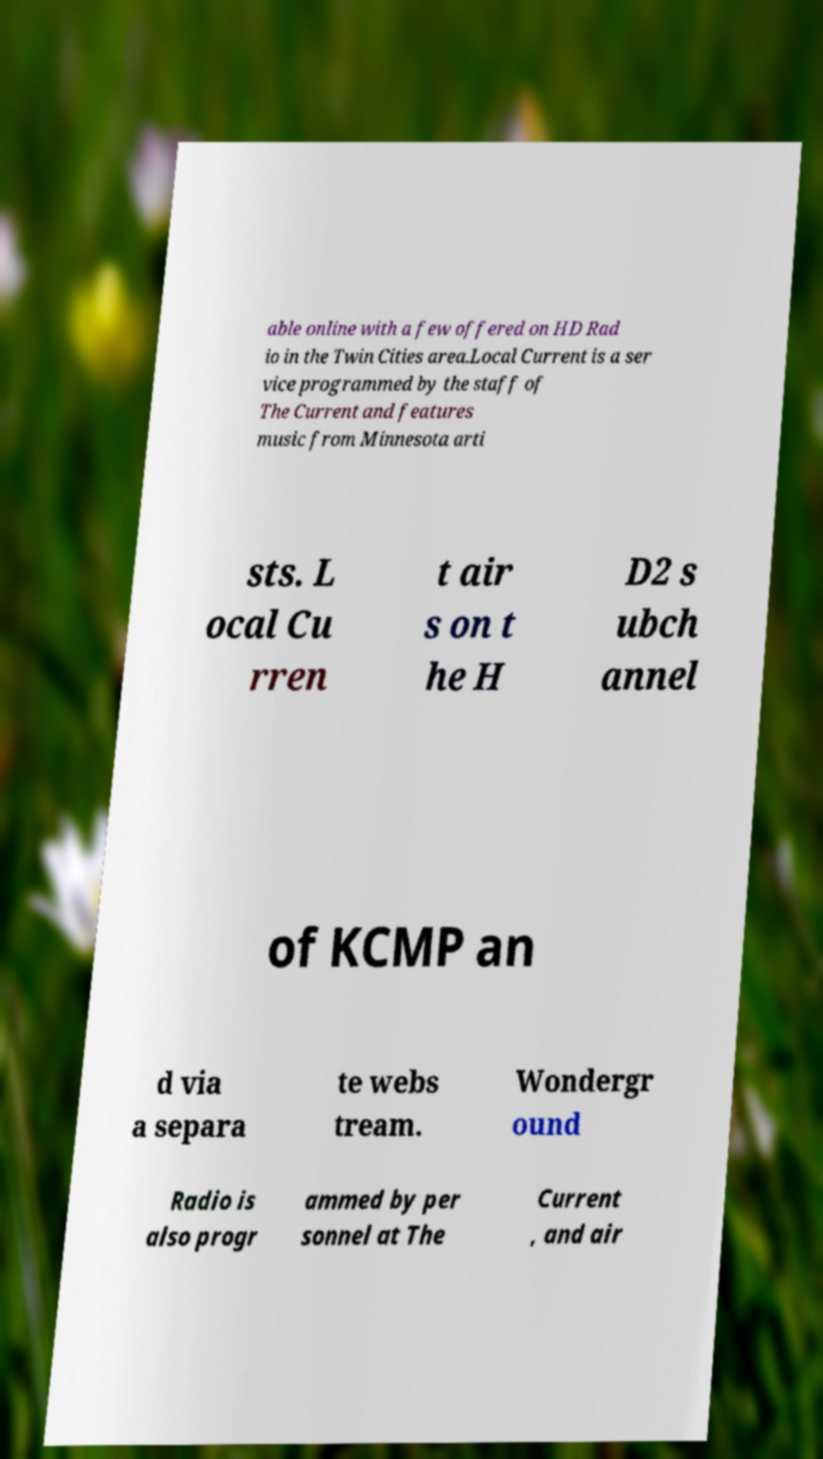Could you extract and type out the text from this image? able online with a few offered on HD Rad io in the Twin Cities area.Local Current is a ser vice programmed by the staff of The Current and features music from Minnesota arti sts. L ocal Cu rren t air s on t he H D2 s ubch annel of KCMP an d via a separa te webs tream. Wondergr ound Radio is also progr ammed by per sonnel at The Current , and air 